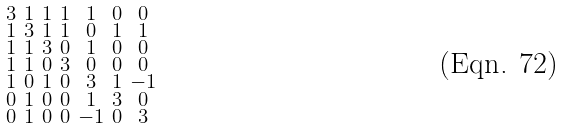<formula> <loc_0><loc_0><loc_500><loc_500>\begin{smallmatrix} 3 & 1 & 1 & 1 & 1 & 0 & 0 \\ 1 & 3 & 1 & 1 & 0 & 1 & 1 \\ 1 & 1 & 3 & 0 & 1 & 0 & 0 \\ 1 & 1 & 0 & 3 & 0 & 0 & 0 \\ 1 & 0 & 1 & 0 & 3 & 1 & - 1 \\ 0 & 1 & 0 & 0 & 1 & 3 & 0 \\ 0 & 1 & 0 & 0 & - 1 & 0 & 3 \end{smallmatrix}</formula> 